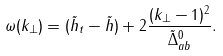Convert formula to latex. <formula><loc_0><loc_0><loc_500><loc_500>\omega ( k _ { \perp } ) = ( \tilde { h } _ { t } - \tilde { h } ) + 2 \frac { ( k _ { \perp } - 1 ) ^ { 2 } } { \tilde { \Delta } _ { a b } ^ { 0 } } .</formula> 